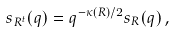Convert formula to latex. <formula><loc_0><loc_0><loc_500><loc_500>s _ { R ^ { t } } ( q ) = q ^ { - \kappa ( R ) / 2 } s _ { R } ( q ) \, ,</formula> 